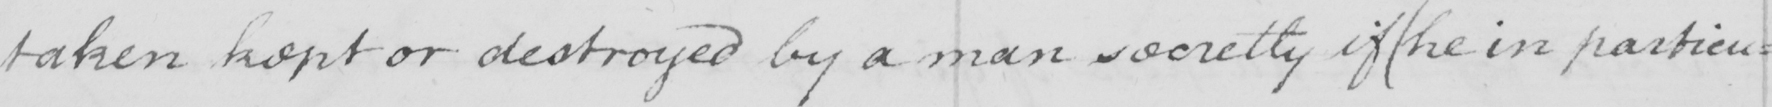What text is written in this handwritten line? taken kept or destroyed by a man secretly if  ( he in particu= 